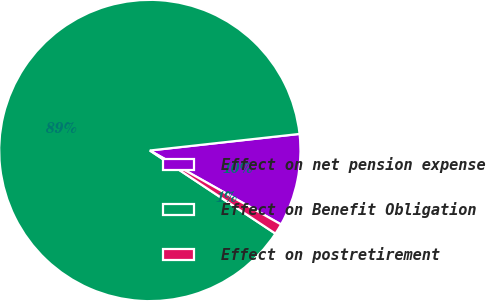Convert chart to OTSL. <chart><loc_0><loc_0><loc_500><loc_500><pie_chart><fcel>Effect on net pension expense<fcel>Effect on Benefit Obligation<fcel>Effect on postretirement<nl><fcel>9.92%<fcel>88.94%<fcel>1.14%<nl></chart> 